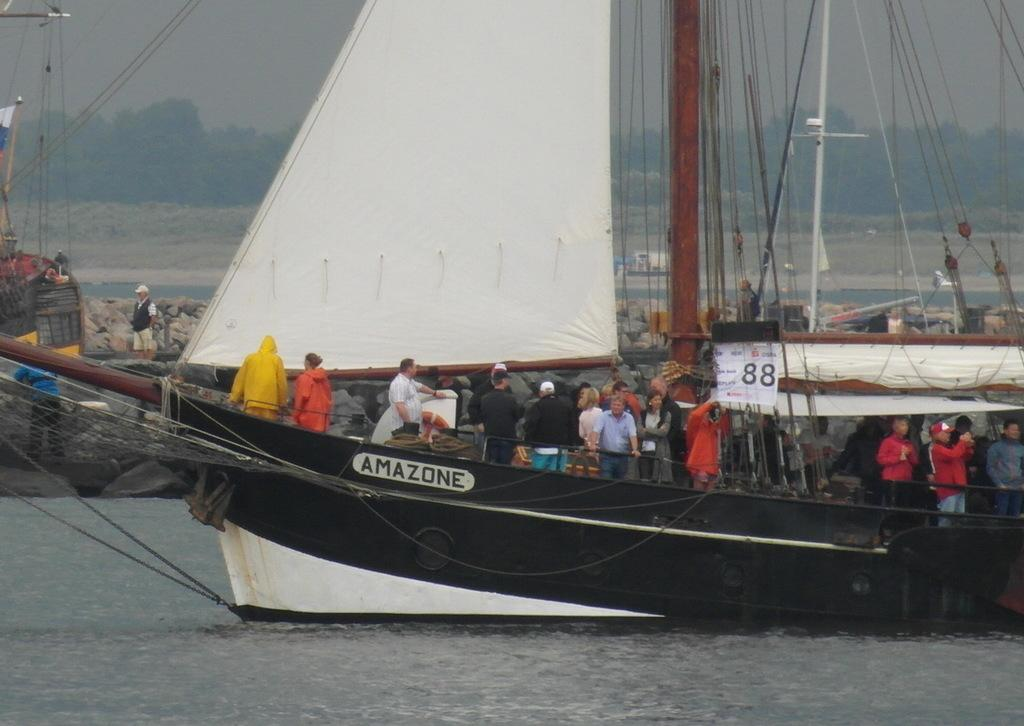What is at the bottom of the image? There is water at the bottom of the image. What is on the water in the image? There is a ship on the water. Who is on the ship in the image? There are people in the ship. What can be seen in the background of the image? There are trees and sky visible in the background of the image. Where are the people located in the image? There are people on the left side of the image. Can you tell me how many icicles are hanging from the ship in the image? There are no icicles present in the image; it features a ship on water with people on board. What type of dock can be seen in the image? There is no dock present in the image; it only shows a ship on water with people on board and a background of trees and sky. 